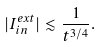<formula> <loc_0><loc_0><loc_500><loc_500>| I _ { i n } ^ { e x t } | \lesssim \frac { 1 } { t ^ { 3 / 4 } } .</formula> 